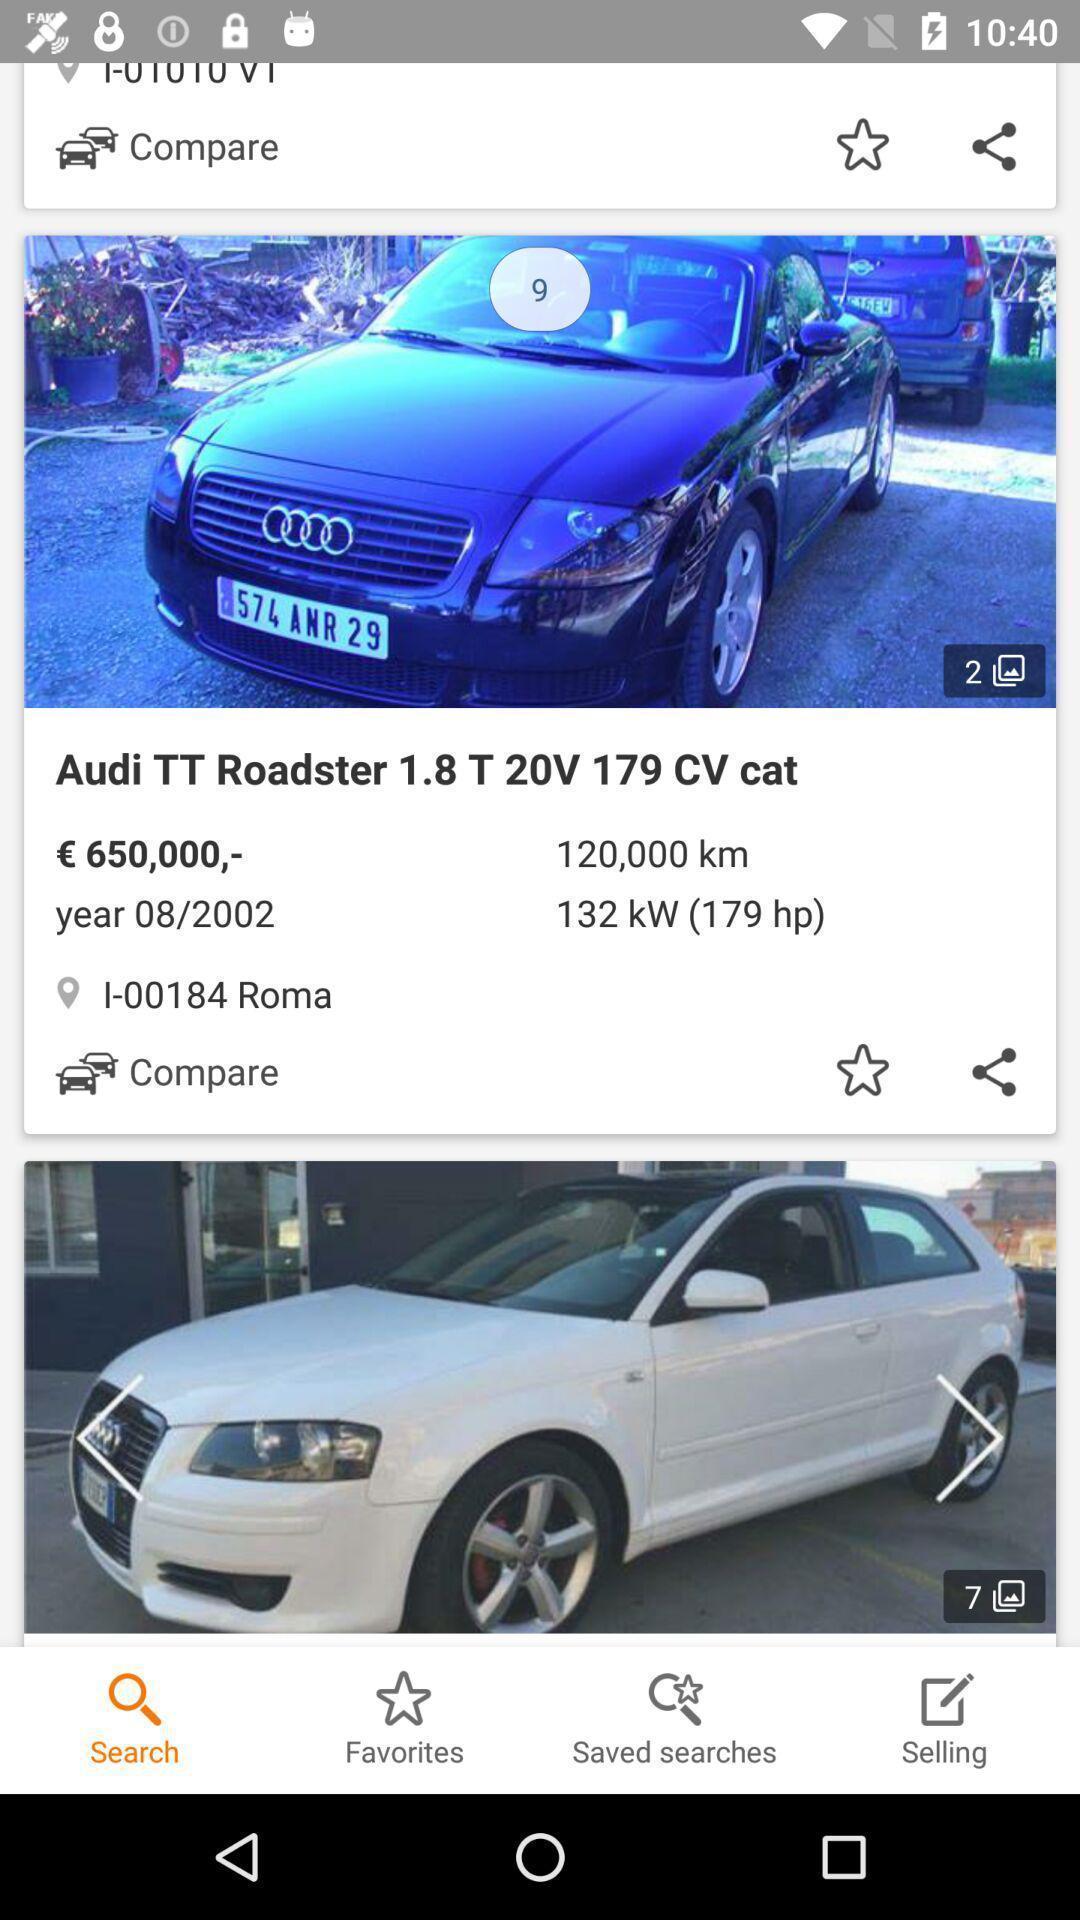Tell me what you see in this picture. Page showing details of cars from a trading app. 